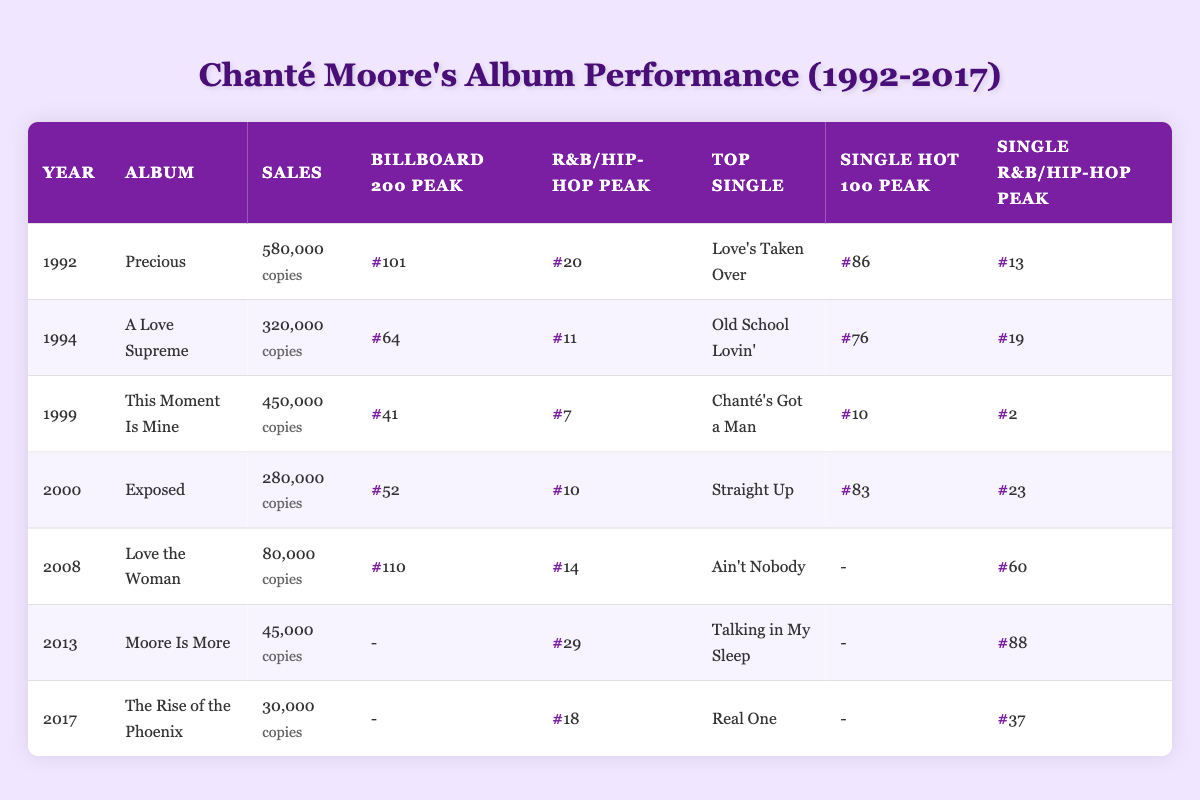What year did Chanté Moore release "This Moment Is Mine"? By scanning the album list in the table, we see "This Moment Is Mine" listed under the year 1999.
Answer: 1999 What was the peak position of "Chanté's Got a Man" on the Hot 100? From the row corresponding to the album "This Moment Is Mine", the peak position of the single "Chanté's Got a Man" on the Hot 100 is noted as 10.
Answer: 10 How many copies did "Precious" sell? In the row for the album "Precious," it clearly states that the album achieved sales of 580,000 copies.
Answer: 580,000 What is the average sales figure of all Chanté Moore's albums listed in the table? Adding up the sales figures: 580,000 + 320,000 + 450,000 + 280,000 + 80,000 + 45,000 + 30,000 = 1,785,000. There are 7 albums total, so the average sales figure is 1,785,000 divided by 7, which equals 255,000.
Answer: 255,000 Did "Moore Is More" reach the Billboard 200 chart? Looking at the data for the album "Moore Is More," it indicates that its peak position on the Billboard 200 is marked as null, which means it did not chart.
Answer: No Which album had the highest R&B/Hip-Hop peak position? By comparing the R&B/Hip-Hop peak positions, the highest is 2, achieved by "Chanté's Got a Man" from the album "This Moment Is Mine."
Answer: This Moment Is Mine What is the total number of albums that peaked in the Billboard 200? Looking over the chart positions for the Billboard 200, the albums with values are "Precious" (101), "A Love Supreme" (64), "This Moment Is Mine" (41), and "Exposed" (52). 4 out of 7 albums peaked in the Billboard 200.
Answer: 4 Which single from "Love the Woman" charted on R&B/Hip-Hop? The single from "Love the Woman," "Ain't Nobody," peaked at position 60 on the R&B/Hip-Hop chart as indicated in the single data for that album.
Answer: 60 What was the audience rating for Chanté Moore's performance at the BET Awards? From the live performances section, the performance at the BET Awards in 2003 for the song "Contagious" had an audience rating of 9.5.
Answer: 9.5 